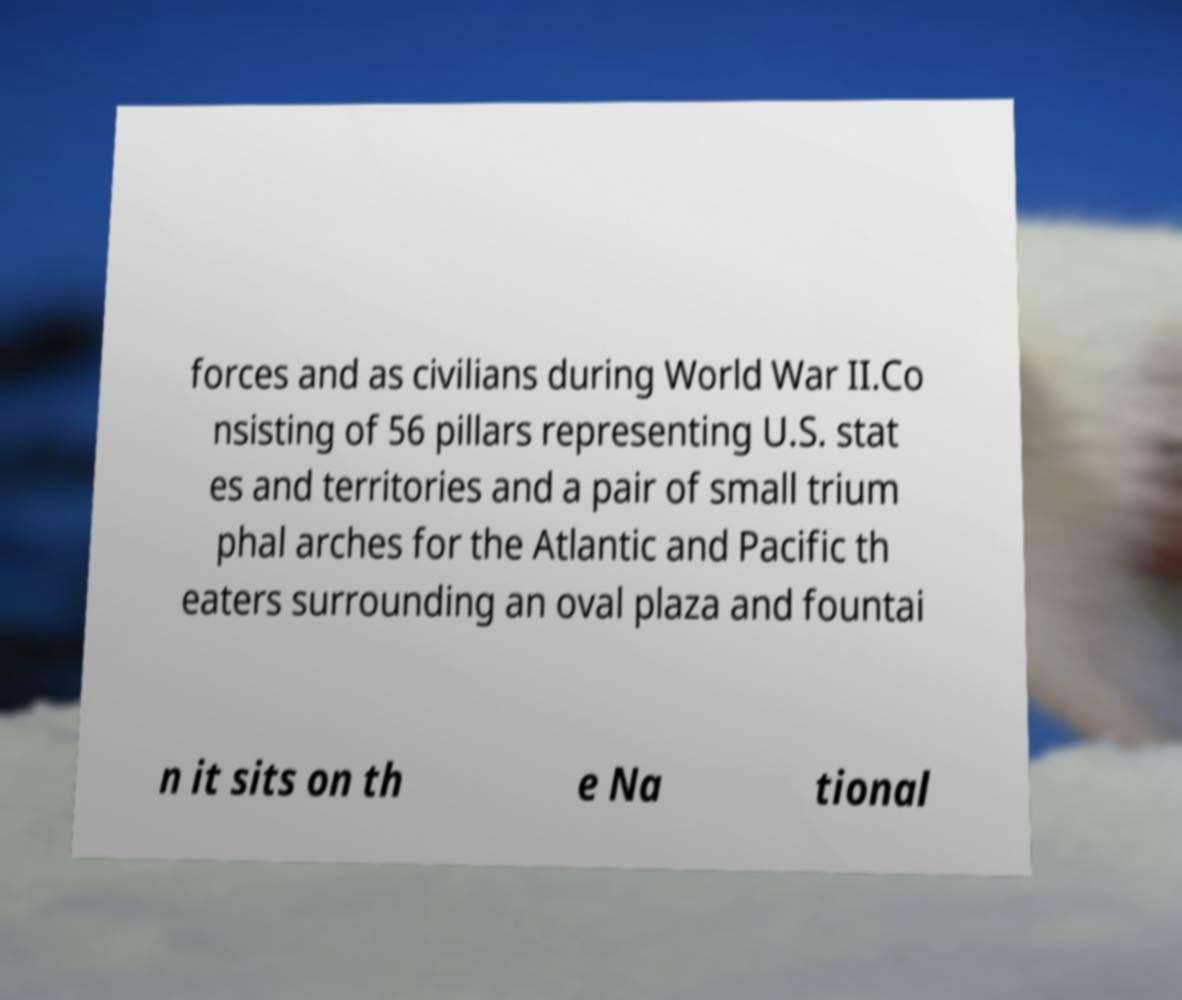Could you assist in decoding the text presented in this image and type it out clearly? forces and as civilians during World War II.Co nsisting of 56 pillars representing U.S. stat es and territories and a pair of small trium phal arches for the Atlantic and Pacific th eaters surrounding an oval plaza and fountai n it sits on th e Na tional 